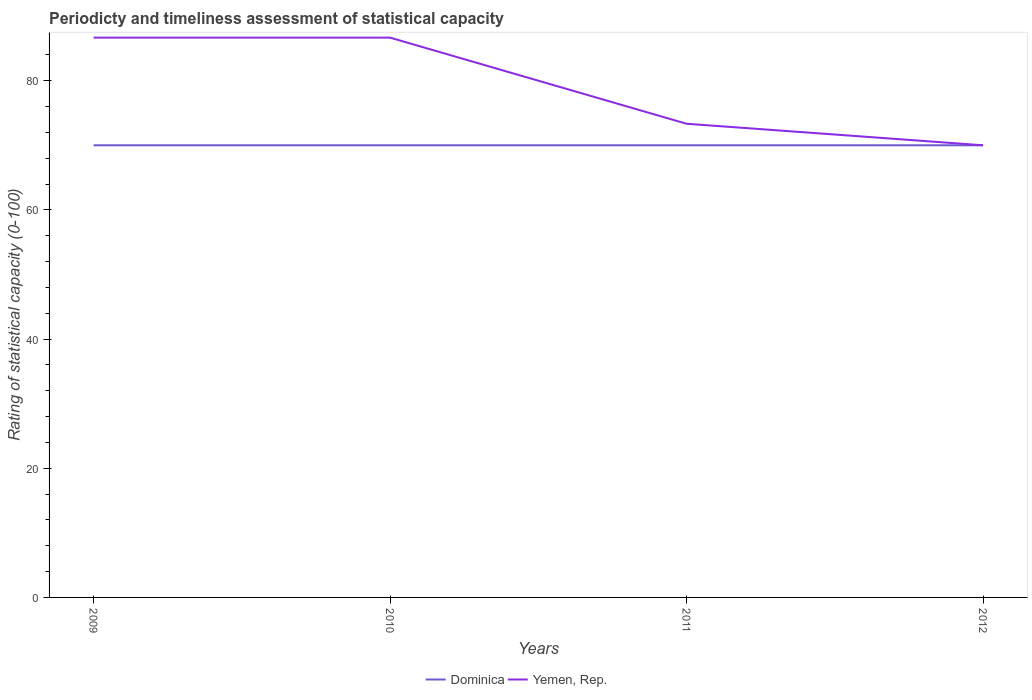How many different coloured lines are there?
Provide a succinct answer. 2. Does the line corresponding to Dominica intersect with the line corresponding to Yemen, Rep.?
Keep it short and to the point. Yes. Is the number of lines equal to the number of legend labels?
Ensure brevity in your answer.  Yes. In which year was the rating of statistical capacity in Dominica maximum?
Your answer should be compact. 2009. What is the total rating of statistical capacity in Dominica in the graph?
Give a very brief answer. 0. What is the difference between the highest and the second highest rating of statistical capacity in Yemen, Rep.?
Give a very brief answer. 16.67. How many lines are there?
Provide a succinct answer. 2. How many years are there in the graph?
Ensure brevity in your answer.  4. Are the values on the major ticks of Y-axis written in scientific E-notation?
Ensure brevity in your answer.  No. Does the graph contain any zero values?
Provide a short and direct response. No. Where does the legend appear in the graph?
Offer a terse response. Bottom center. What is the title of the graph?
Provide a short and direct response. Periodicty and timeliness assessment of statistical capacity. Does "Singapore" appear as one of the legend labels in the graph?
Offer a very short reply. No. What is the label or title of the Y-axis?
Provide a short and direct response. Rating of statistical capacity (0-100). What is the Rating of statistical capacity (0-100) of Yemen, Rep. in 2009?
Your answer should be very brief. 86.67. What is the Rating of statistical capacity (0-100) in Yemen, Rep. in 2010?
Give a very brief answer. 86.67. What is the Rating of statistical capacity (0-100) of Dominica in 2011?
Provide a short and direct response. 70. What is the Rating of statistical capacity (0-100) of Yemen, Rep. in 2011?
Offer a very short reply. 73.33. What is the Rating of statistical capacity (0-100) in Yemen, Rep. in 2012?
Make the answer very short. 70. Across all years, what is the maximum Rating of statistical capacity (0-100) in Yemen, Rep.?
Give a very brief answer. 86.67. Across all years, what is the minimum Rating of statistical capacity (0-100) of Dominica?
Give a very brief answer. 70. What is the total Rating of statistical capacity (0-100) in Dominica in the graph?
Your response must be concise. 280. What is the total Rating of statistical capacity (0-100) in Yemen, Rep. in the graph?
Your answer should be compact. 316.67. What is the difference between the Rating of statistical capacity (0-100) of Yemen, Rep. in 2009 and that in 2010?
Your answer should be compact. 0. What is the difference between the Rating of statistical capacity (0-100) of Dominica in 2009 and that in 2011?
Your response must be concise. 0. What is the difference between the Rating of statistical capacity (0-100) in Yemen, Rep. in 2009 and that in 2011?
Offer a very short reply. 13.33. What is the difference between the Rating of statistical capacity (0-100) of Dominica in 2009 and that in 2012?
Make the answer very short. 0. What is the difference between the Rating of statistical capacity (0-100) of Yemen, Rep. in 2009 and that in 2012?
Offer a very short reply. 16.67. What is the difference between the Rating of statistical capacity (0-100) in Yemen, Rep. in 2010 and that in 2011?
Provide a succinct answer. 13.33. What is the difference between the Rating of statistical capacity (0-100) in Yemen, Rep. in 2010 and that in 2012?
Give a very brief answer. 16.67. What is the difference between the Rating of statistical capacity (0-100) of Dominica in 2011 and that in 2012?
Make the answer very short. 0. What is the difference between the Rating of statistical capacity (0-100) in Yemen, Rep. in 2011 and that in 2012?
Your answer should be compact. 3.33. What is the difference between the Rating of statistical capacity (0-100) of Dominica in 2009 and the Rating of statistical capacity (0-100) of Yemen, Rep. in 2010?
Offer a very short reply. -16.67. What is the difference between the Rating of statistical capacity (0-100) of Dominica in 2009 and the Rating of statistical capacity (0-100) of Yemen, Rep. in 2011?
Your answer should be very brief. -3.33. What is the average Rating of statistical capacity (0-100) in Dominica per year?
Provide a succinct answer. 70. What is the average Rating of statistical capacity (0-100) of Yemen, Rep. per year?
Keep it short and to the point. 79.17. In the year 2009, what is the difference between the Rating of statistical capacity (0-100) in Dominica and Rating of statistical capacity (0-100) in Yemen, Rep.?
Make the answer very short. -16.67. In the year 2010, what is the difference between the Rating of statistical capacity (0-100) in Dominica and Rating of statistical capacity (0-100) in Yemen, Rep.?
Give a very brief answer. -16.67. In the year 2011, what is the difference between the Rating of statistical capacity (0-100) in Dominica and Rating of statistical capacity (0-100) in Yemen, Rep.?
Keep it short and to the point. -3.33. In the year 2012, what is the difference between the Rating of statistical capacity (0-100) in Dominica and Rating of statistical capacity (0-100) in Yemen, Rep.?
Offer a very short reply. 0. What is the ratio of the Rating of statistical capacity (0-100) of Yemen, Rep. in 2009 to that in 2011?
Provide a succinct answer. 1.18. What is the ratio of the Rating of statistical capacity (0-100) of Dominica in 2009 to that in 2012?
Offer a terse response. 1. What is the ratio of the Rating of statistical capacity (0-100) in Yemen, Rep. in 2009 to that in 2012?
Keep it short and to the point. 1.24. What is the ratio of the Rating of statistical capacity (0-100) of Yemen, Rep. in 2010 to that in 2011?
Your response must be concise. 1.18. What is the ratio of the Rating of statistical capacity (0-100) of Dominica in 2010 to that in 2012?
Provide a short and direct response. 1. What is the ratio of the Rating of statistical capacity (0-100) in Yemen, Rep. in 2010 to that in 2012?
Ensure brevity in your answer.  1.24. What is the ratio of the Rating of statistical capacity (0-100) of Yemen, Rep. in 2011 to that in 2012?
Your answer should be very brief. 1.05. What is the difference between the highest and the second highest Rating of statistical capacity (0-100) of Yemen, Rep.?
Ensure brevity in your answer.  0. What is the difference between the highest and the lowest Rating of statistical capacity (0-100) in Yemen, Rep.?
Your answer should be very brief. 16.67. 